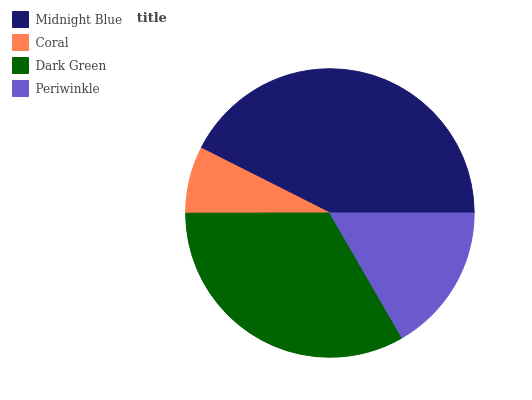Is Coral the minimum?
Answer yes or no. Yes. Is Midnight Blue the maximum?
Answer yes or no. Yes. Is Dark Green the minimum?
Answer yes or no. No. Is Dark Green the maximum?
Answer yes or no. No. Is Dark Green greater than Coral?
Answer yes or no. Yes. Is Coral less than Dark Green?
Answer yes or no. Yes. Is Coral greater than Dark Green?
Answer yes or no. No. Is Dark Green less than Coral?
Answer yes or no. No. Is Dark Green the high median?
Answer yes or no. Yes. Is Periwinkle the low median?
Answer yes or no. Yes. Is Periwinkle the high median?
Answer yes or no. No. Is Dark Green the low median?
Answer yes or no. No. 